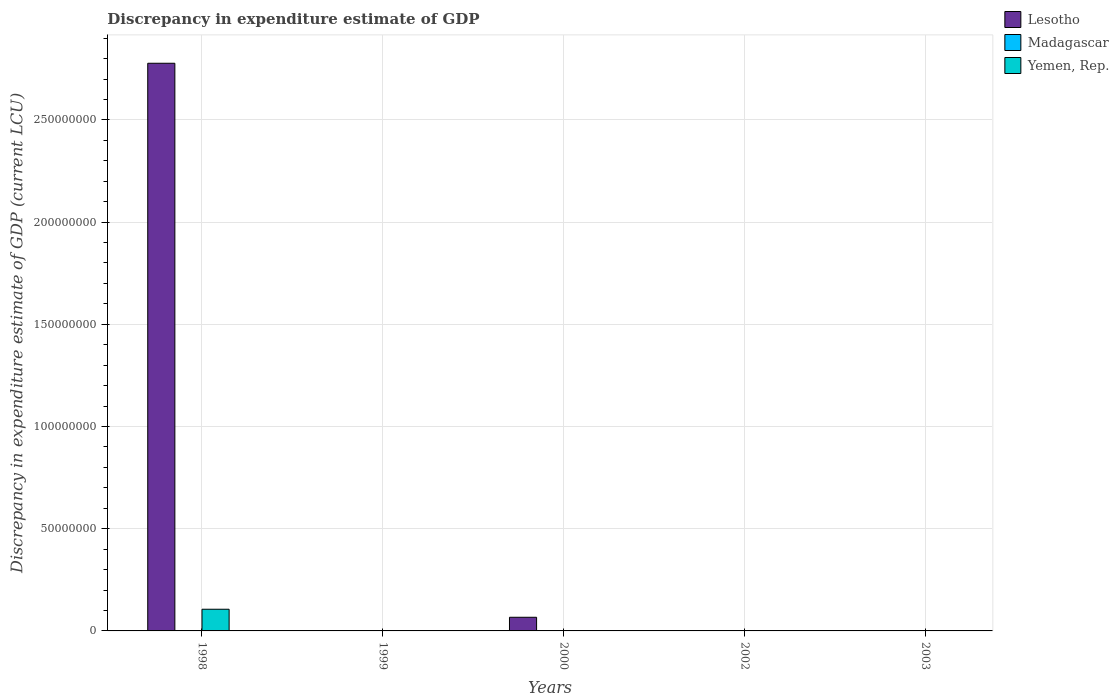Are the number of bars on each tick of the X-axis equal?
Ensure brevity in your answer.  No. How many bars are there on the 5th tick from the left?
Your response must be concise. 0. How many bars are there on the 3rd tick from the right?
Your answer should be compact. 2. What is the label of the 2nd group of bars from the left?
Your answer should be very brief. 1999. In how many cases, is the number of bars for a given year not equal to the number of legend labels?
Provide a short and direct response. 5. Across all years, what is the maximum discrepancy in expenditure estimate of GDP in Lesotho?
Your response must be concise. 2.78e+08. In which year was the discrepancy in expenditure estimate of GDP in Yemen, Rep. maximum?
Make the answer very short. 1998. What is the total discrepancy in expenditure estimate of GDP in Lesotho in the graph?
Keep it short and to the point. 2.84e+08. What is the difference between the discrepancy in expenditure estimate of GDP in Madagascar in 2003 and the discrepancy in expenditure estimate of GDP in Lesotho in 1998?
Provide a short and direct response. -2.78e+08. What is the average discrepancy in expenditure estimate of GDP in Yemen, Rep. per year?
Make the answer very short. 2.12e+06. In the year 1998, what is the difference between the discrepancy in expenditure estimate of GDP in Lesotho and discrepancy in expenditure estimate of GDP in Yemen, Rep.?
Your answer should be compact. 2.67e+08. What is the difference between the highest and the lowest discrepancy in expenditure estimate of GDP in Lesotho?
Keep it short and to the point. 2.78e+08. In how many years, is the discrepancy in expenditure estimate of GDP in Yemen, Rep. greater than the average discrepancy in expenditure estimate of GDP in Yemen, Rep. taken over all years?
Offer a terse response. 1. Is it the case that in every year, the sum of the discrepancy in expenditure estimate of GDP in Yemen, Rep. and discrepancy in expenditure estimate of GDP in Madagascar is greater than the discrepancy in expenditure estimate of GDP in Lesotho?
Give a very brief answer. No. How many years are there in the graph?
Your answer should be very brief. 5. What is the difference between two consecutive major ticks on the Y-axis?
Keep it short and to the point. 5.00e+07. Does the graph contain any zero values?
Ensure brevity in your answer.  Yes. Does the graph contain grids?
Keep it short and to the point. Yes. How many legend labels are there?
Ensure brevity in your answer.  3. How are the legend labels stacked?
Your answer should be very brief. Vertical. What is the title of the graph?
Make the answer very short. Discrepancy in expenditure estimate of GDP. Does "Central African Republic" appear as one of the legend labels in the graph?
Provide a succinct answer. No. What is the label or title of the Y-axis?
Offer a very short reply. Discrepancy in expenditure estimate of GDP (current LCU). What is the Discrepancy in expenditure estimate of GDP (current LCU) of Lesotho in 1998?
Your response must be concise. 2.78e+08. What is the Discrepancy in expenditure estimate of GDP (current LCU) in Madagascar in 1998?
Provide a short and direct response. 0. What is the Discrepancy in expenditure estimate of GDP (current LCU) in Yemen, Rep. in 1998?
Your answer should be very brief. 1.06e+07. What is the Discrepancy in expenditure estimate of GDP (current LCU) of Lesotho in 1999?
Provide a short and direct response. 0. What is the Discrepancy in expenditure estimate of GDP (current LCU) in Madagascar in 1999?
Ensure brevity in your answer.  0. What is the Discrepancy in expenditure estimate of GDP (current LCU) in Lesotho in 2000?
Provide a succinct answer. 6.68e+06. What is the Discrepancy in expenditure estimate of GDP (current LCU) in Madagascar in 2000?
Your answer should be compact. 0. What is the Discrepancy in expenditure estimate of GDP (current LCU) in Yemen, Rep. in 2000?
Keep it short and to the point. 0. What is the Discrepancy in expenditure estimate of GDP (current LCU) of Madagascar in 2002?
Your answer should be very brief. 0. Across all years, what is the maximum Discrepancy in expenditure estimate of GDP (current LCU) in Lesotho?
Provide a succinct answer. 2.78e+08. Across all years, what is the maximum Discrepancy in expenditure estimate of GDP (current LCU) of Madagascar?
Your answer should be compact. 0. Across all years, what is the maximum Discrepancy in expenditure estimate of GDP (current LCU) in Yemen, Rep.?
Provide a succinct answer. 1.06e+07. Across all years, what is the minimum Discrepancy in expenditure estimate of GDP (current LCU) in Lesotho?
Ensure brevity in your answer.  0. Across all years, what is the minimum Discrepancy in expenditure estimate of GDP (current LCU) of Madagascar?
Ensure brevity in your answer.  0. What is the total Discrepancy in expenditure estimate of GDP (current LCU) in Lesotho in the graph?
Give a very brief answer. 2.84e+08. What is the total Discrepancy in expenditure estimate of GDP (current LCU) in Madagascar in the graph?
Your answer should be very brief. 0. What is the total Discrepancy in expenditure estimate of GDP (current LCU) of Yemen, Rep. in the graph?
Make the answer very short. 1.06e+07. What is the difference between the Discrepancy in expenditure estimate of GDP (current LCU) of Lesotho in 1998 and that in 2000?
Your answer should be compact. 2.71e+08. What is the difference between the Discrepancy in expenditure estimate of GDP (current LCU) of Lesotho in 1998 and the Discrepancy in expenditure estimate of GDP (current LCU) of Madagascar in 2000?
Give a very brief answer. 2.78e+08. What is the average Discrepancy in expenditure estimate of GDP (current LCU) in Lesotho per year?
Ensure brevity in your answer.  5.69e+07. What is the average Discrepancy in expenditure estimate of GDP (current LCU) of Madagascar per year?
Your response must be concise. 0. What is the average Discrepancy in expenditure estimate of GDP (current LCU) in Yemen, Rep. per year?
Give a very brief answer. 2.12e+06. In the year 1998, what is the difference between the Discrepancy in expenditure estimate of GDP (current LCU) of Lesotho and Discrepancy in expenditure estimate of GDP (current LCU) of Yemen, Rep.?
Your answer should be very brief. 2.67e+08. In the year 2000, what is the difference between the Discrepancy in expenditure estimate of GDP (current LCU) of Lesotho and Discrepancy in expenditure estimate of GDP (current LCU) of Madagascar?
Keep it short and to the point. 6.68e+06. What is the ratio of the Discrepancy in expenditure estimate of GDP (current LCU) of Lesotho in 1998 to that in 2000?
Your response must be concise. 41.58. What is the difference between the highest and the lowest Discrepancy in expenditure estimate of GDP (current LCU) of Lesotho?
Your answer should be compact. 2.78e+08. What is the difference between the highest and the lowest Discrepancy in expenditure estimate of GDP (current LCU) of Madagascar?
Make the answer very short. 0. What is the difference between the highest and the lowest Discrepancy in expenditure estimate of GDP (current LCU) of Yemen, Rep.?
Keep it short and to the point. 1.06e+07. 